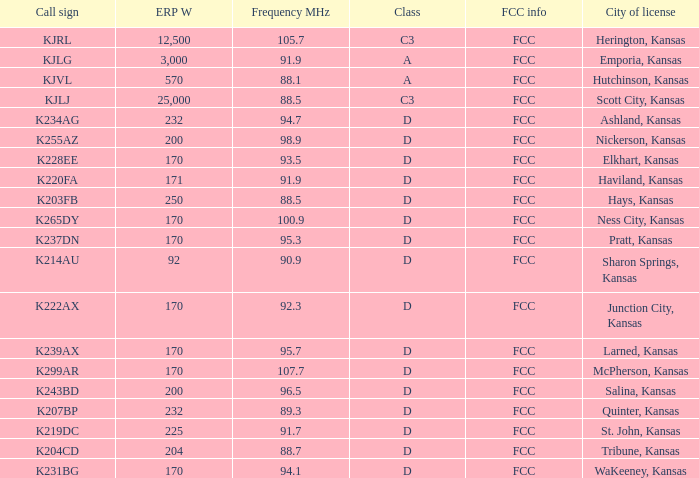Class of d, and a Frequency MHz smaller than 107.7, and a ERP W smaller than 232 has what call sign? K255AZ, K228EE, K220FA, K265DY, K237DN, K214AU, K222AX, K239AX, K243BD, K219DC, K204CD, K231BG. 